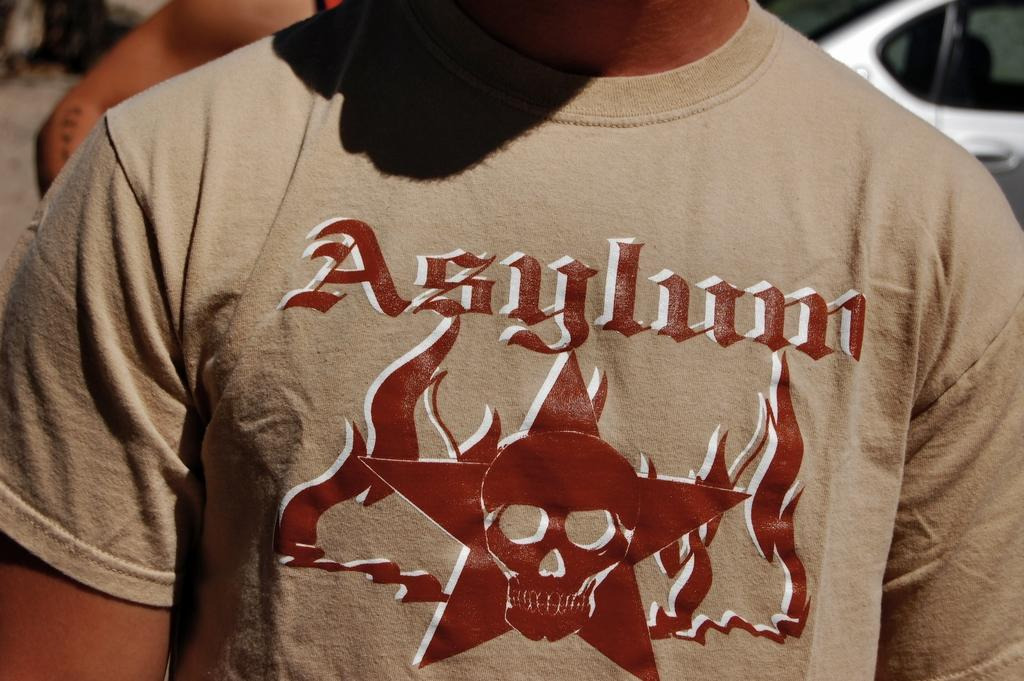<image>
Share a concise interpretation of the image provided. a shirt that has the word asylum on it 